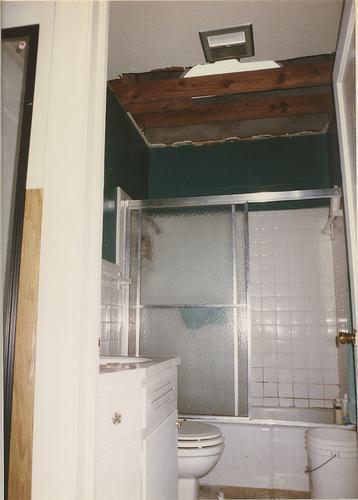How many toilets?
Give a very brief answer. 1. 